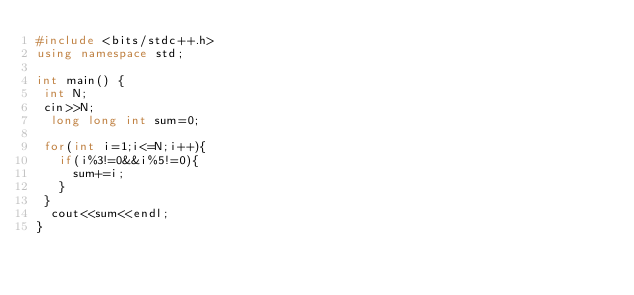<code> <loc_0><loc_0><loc_500><loc_500><_C++_>#include <bits/stdc++.h>
using namespace std;

int main() {
 int N;
 cin>>N;
  long long int sum=0;
  
 for(int i=1;i<=N;i++){
   if(i%3!=0&&i%5!=0){
     sum+=i;
   }
 }
  cout<<sum<<endl;
}
  

</code> 